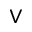<formula> <loc_0><loc_0><loc_500><loc_500>\vee</formula> 